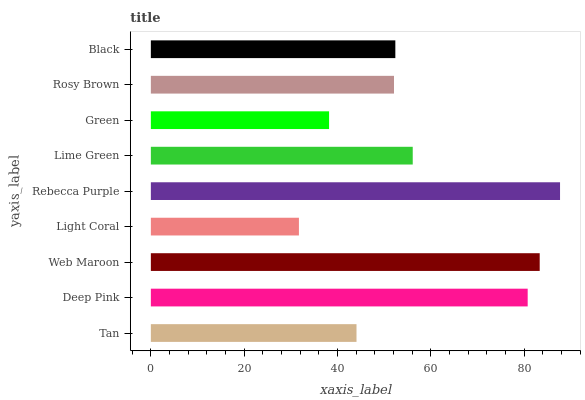Is Light Coral the minimum?
Answer yes or no. Yes. Is Rebecca Purple the maximum?
Answer yes or no. Yes. Is Deep Pink the minimum?
Answer yes or no. No. Is Deep Pink the maximum?
Answer yes or no. No. Is Deep Pink greater than Tan?
Answer yes or no. Yes. Is Tan less than Deep Pink?
Answer yes or no. Yes. Is Tan greater than Deep Pink?
Answer yes or no. No. Is Deep Pink less than Tan?
Answer yes or no. No. Is Black the high median?
Answer yes or no. Yes. Is Black the low median?
Answer yes or no. Yes. Is Web Maroon the high median?
Answer yes or no. No. Is Tan the low median?
Answer yes or no. No. 